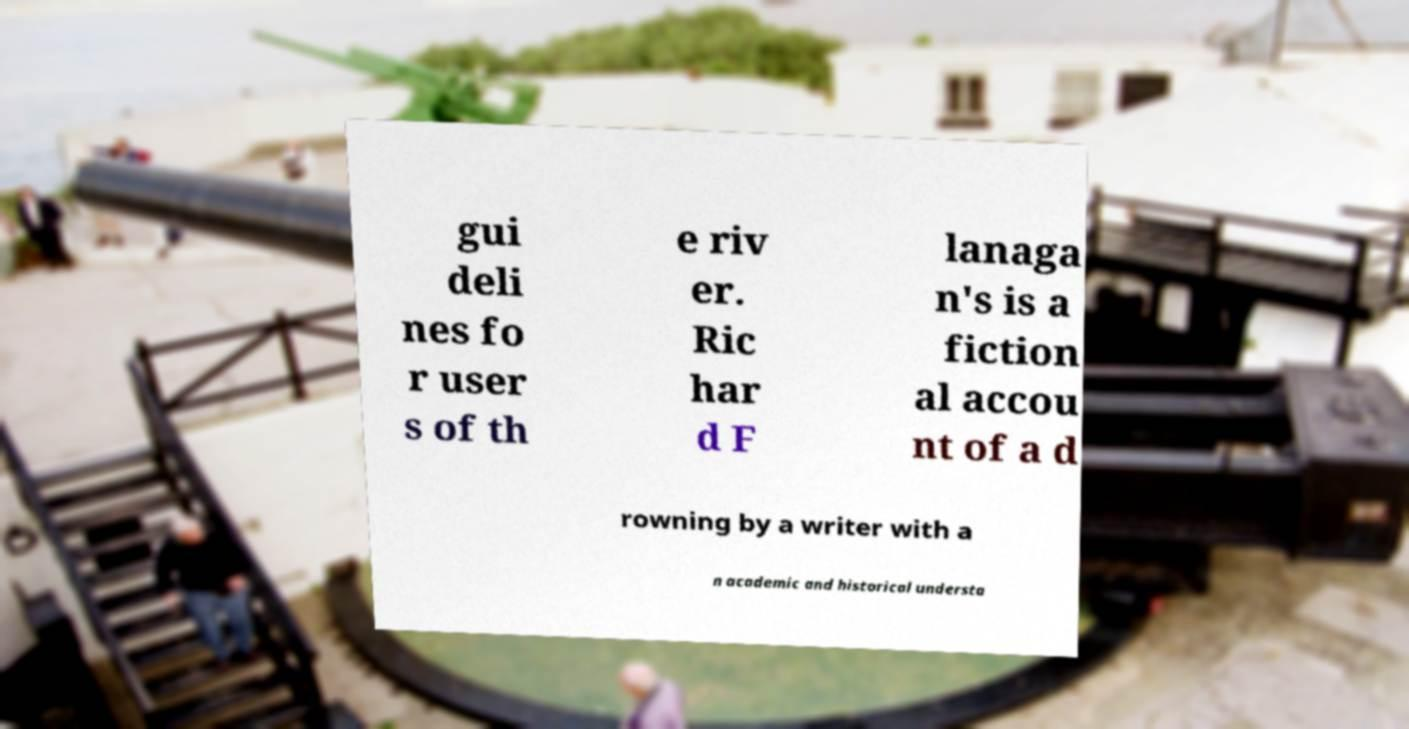Please read and relay the text visible in this image. What does it say? gui deli nes fo r user s of th e riv er. Ric har d F lanaga n's is a fiction al accou nt of a d rowning by a writer with a n academic and historical understa 